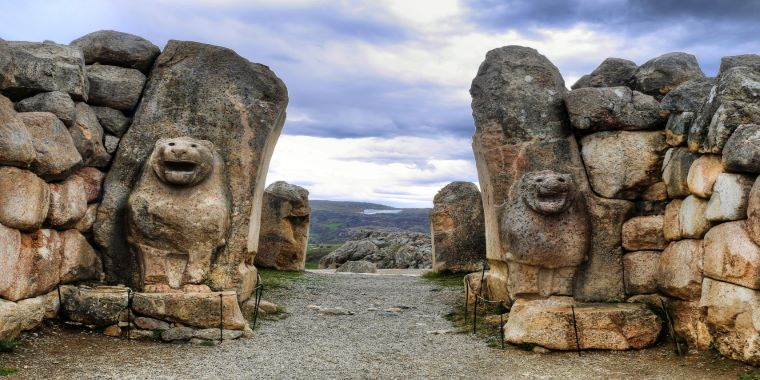Analyze the image in a comprehensive and detailed manner.
 The image captures the imposing Lion Gate at Hattusa, Turkey. The gate, constructed from large stones, is a testament to the architectural prowess of the ancient Hittites. It is flanked by two lion sculptures, carved directly into the stone, their gazes fixed forward in a silent and eternal vigil. The gate stands against a backdrop of towering mountains and a sky filled with clouds, adding to its grandeur. The perspective of the image is from the ground, looking up at the gate, which enhances the sense of scale and majesty of this historic landmark. The image is a striking representation of the rich history and cultural heritage of Turkey. 